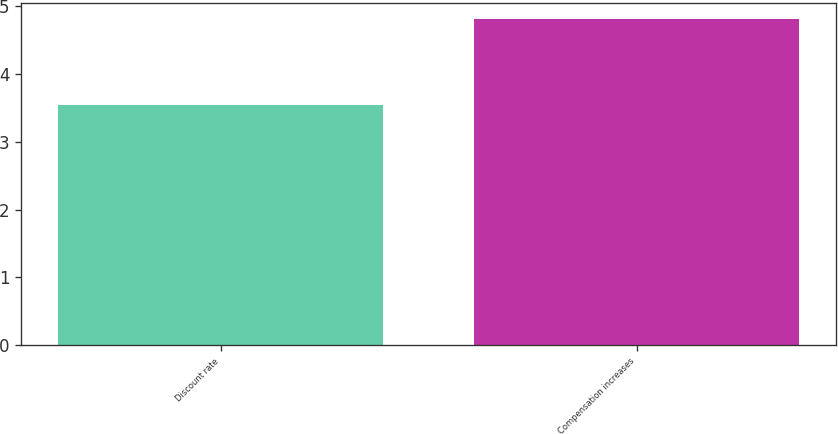Convert chart. <chart><loc_0><loc_0><loc_500><loc_500><bar_chart><fcel>Discount rate<fcel>Compensation increases<nl><fcel>3.55<fcel>4.81<nl></chart> 